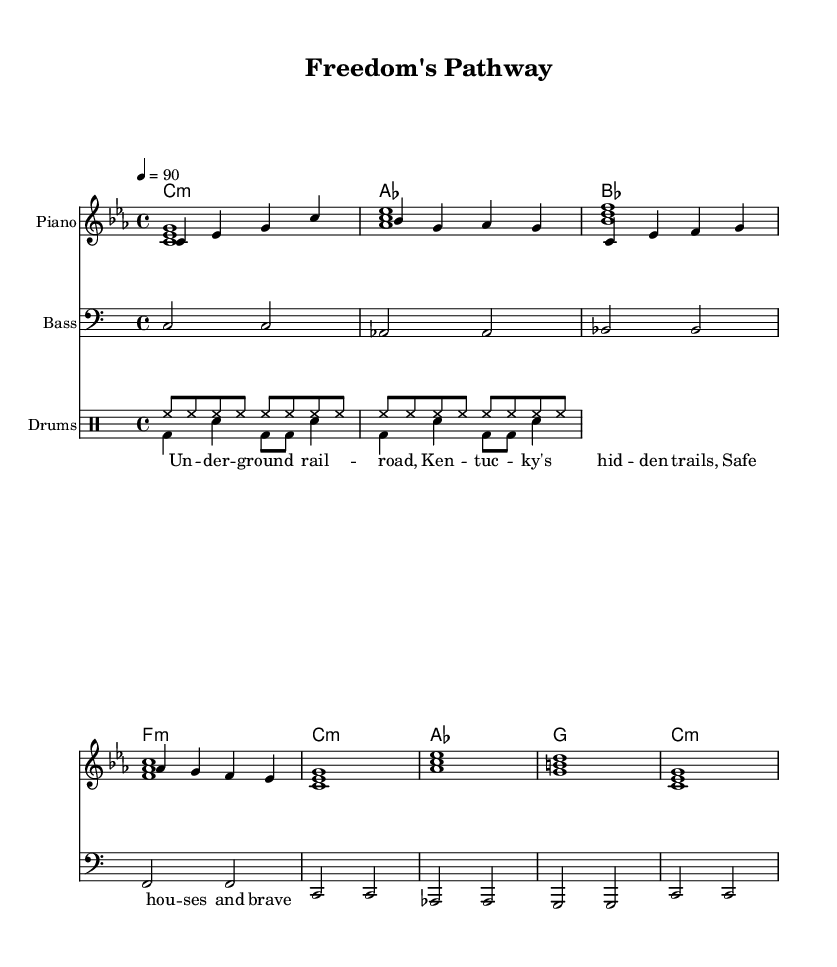What is the key signature of this music? The key signature is C minor, indicated by three flat notes (B♭, E♭, A♭) based on the scale used, which is derived from the relative major, E♭ major.
Answer: C minor What is the time signature of this music? The time signature shown in the sheet music is 4/4, which indicates there are four beats per measure and the quarter note receives one beat.
Answer: 4/4 What is the tempo marking of this piece? The tempo marking indicates a speed of 90 beats per minute, which tells the performer how fast to play the piece.
Answer: 90 How many measures are indicated in the melody section? The melody section contains two measures as indicated by the grouping of notes which fit within the defined 4/4 time signature.
Answer: 2 What type of music genre does this piece represent? The sheet music is labeled as a hip hop track, evidenced by the structured beat patterns and lyrical content reflecting themes relevant to hip hop culture and history.
Answer: Hip hop What lyric theme is reflected in the music? The lyrics highlight themes of the Underground Railroad, referencing the struggle for freedom and the secret routes used in Kentucky for escaping slaves.
Answer: Freedom and the Underground Railroad What instruments are represented in this score? The score features piano, bass, and drums, with distinct sections for each instrument to provide harmonic and rhythmic support to the musical arrangement.
Answer: Piano, bass, drums 